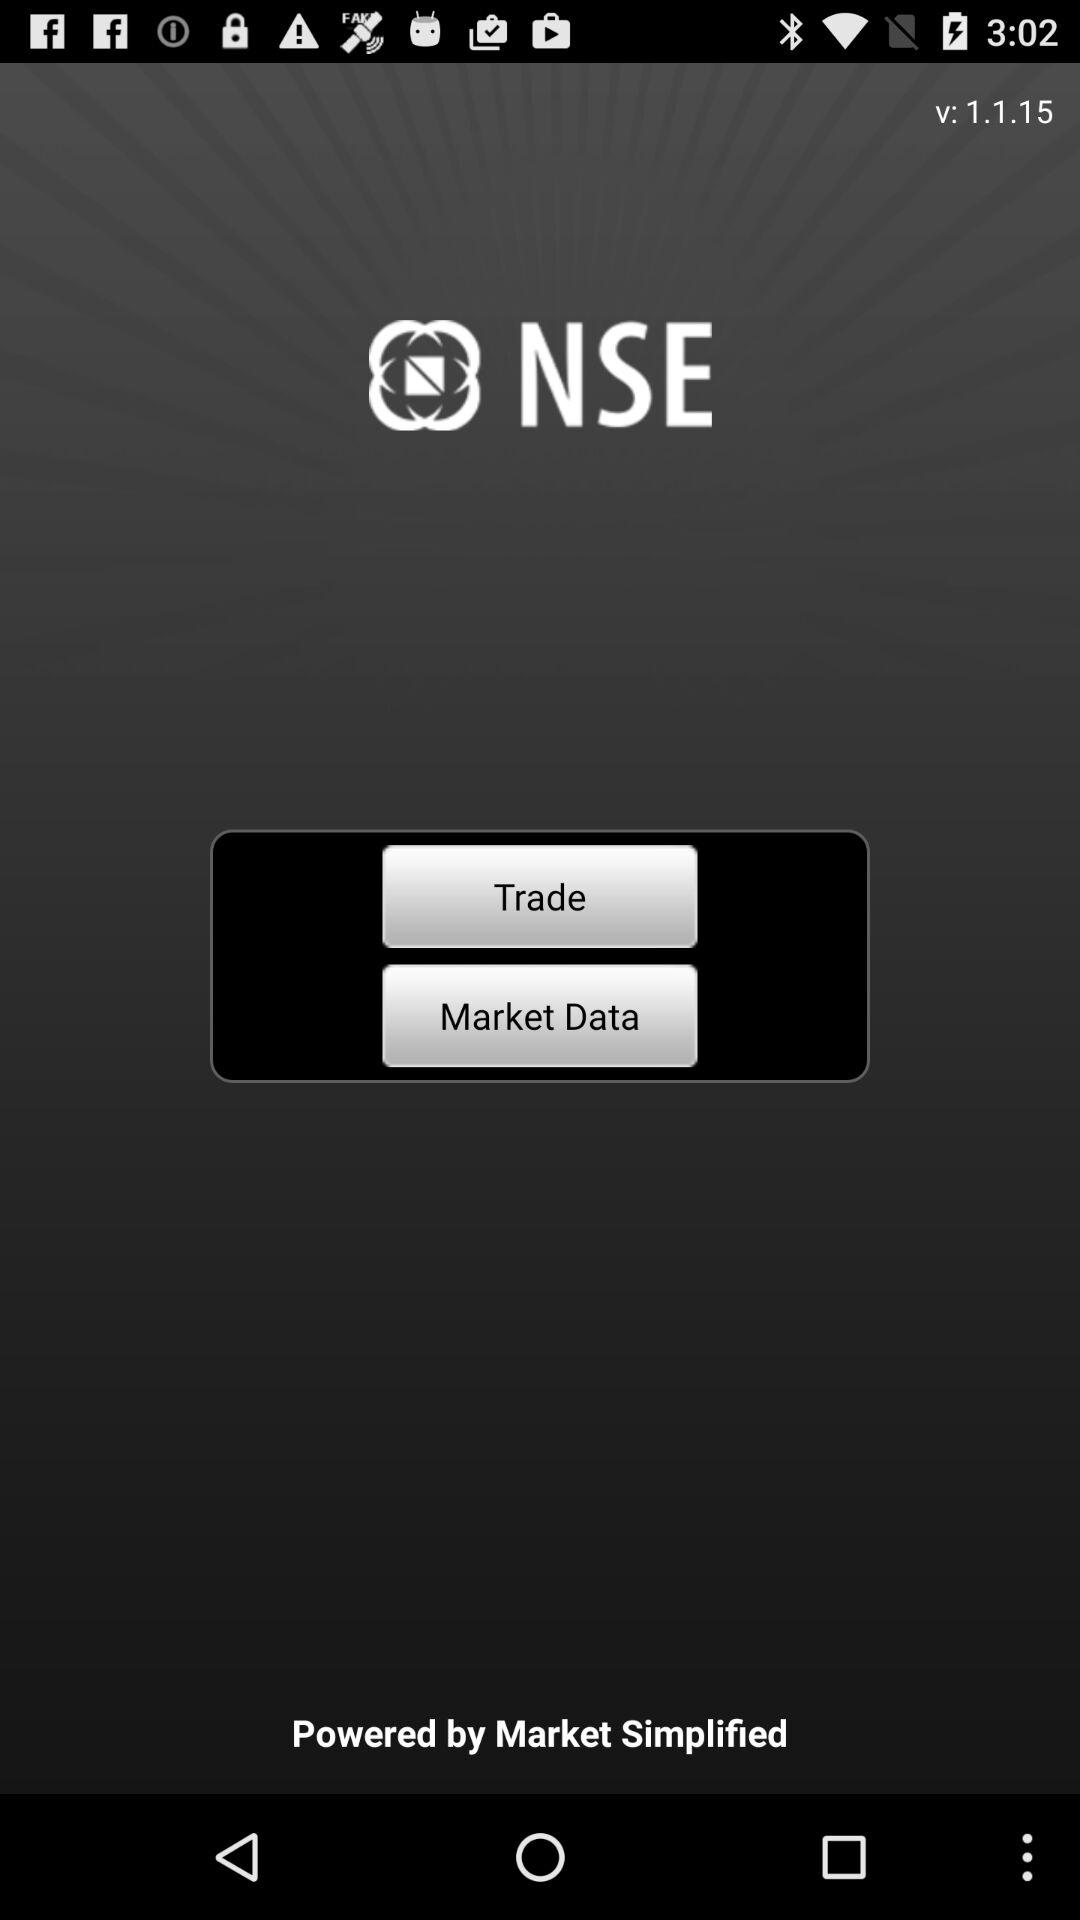What is the application name? The application name is "NSE". 